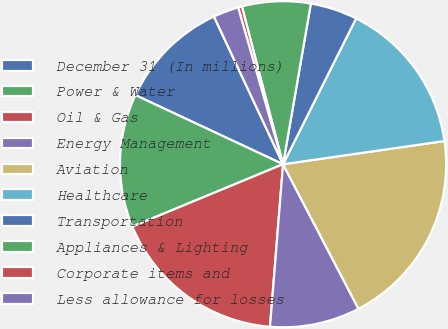<chart> <loc_0><loc_0><loc_500><loc_500><pie_chart><fcel>December 31 (In millions)<fcel>Power & Water<fcel>Oil & Gas<fcel>Energy Management<fcel>Aviation<fcel>Healthcare<fcel>Transportation<fcel>Appliances & Lighting<fcel>Corporate items and<fcel>Less allowance for losses<nl><fcel>11.07%<fcel>13.21%<fcel>17.48%<fcel>8.93%<fcel>19.62%<fcel>15.34%<fcel>4.66%<fcel>6.79%<fcel>0.38%<fcel>2.52%<nl></chart> 